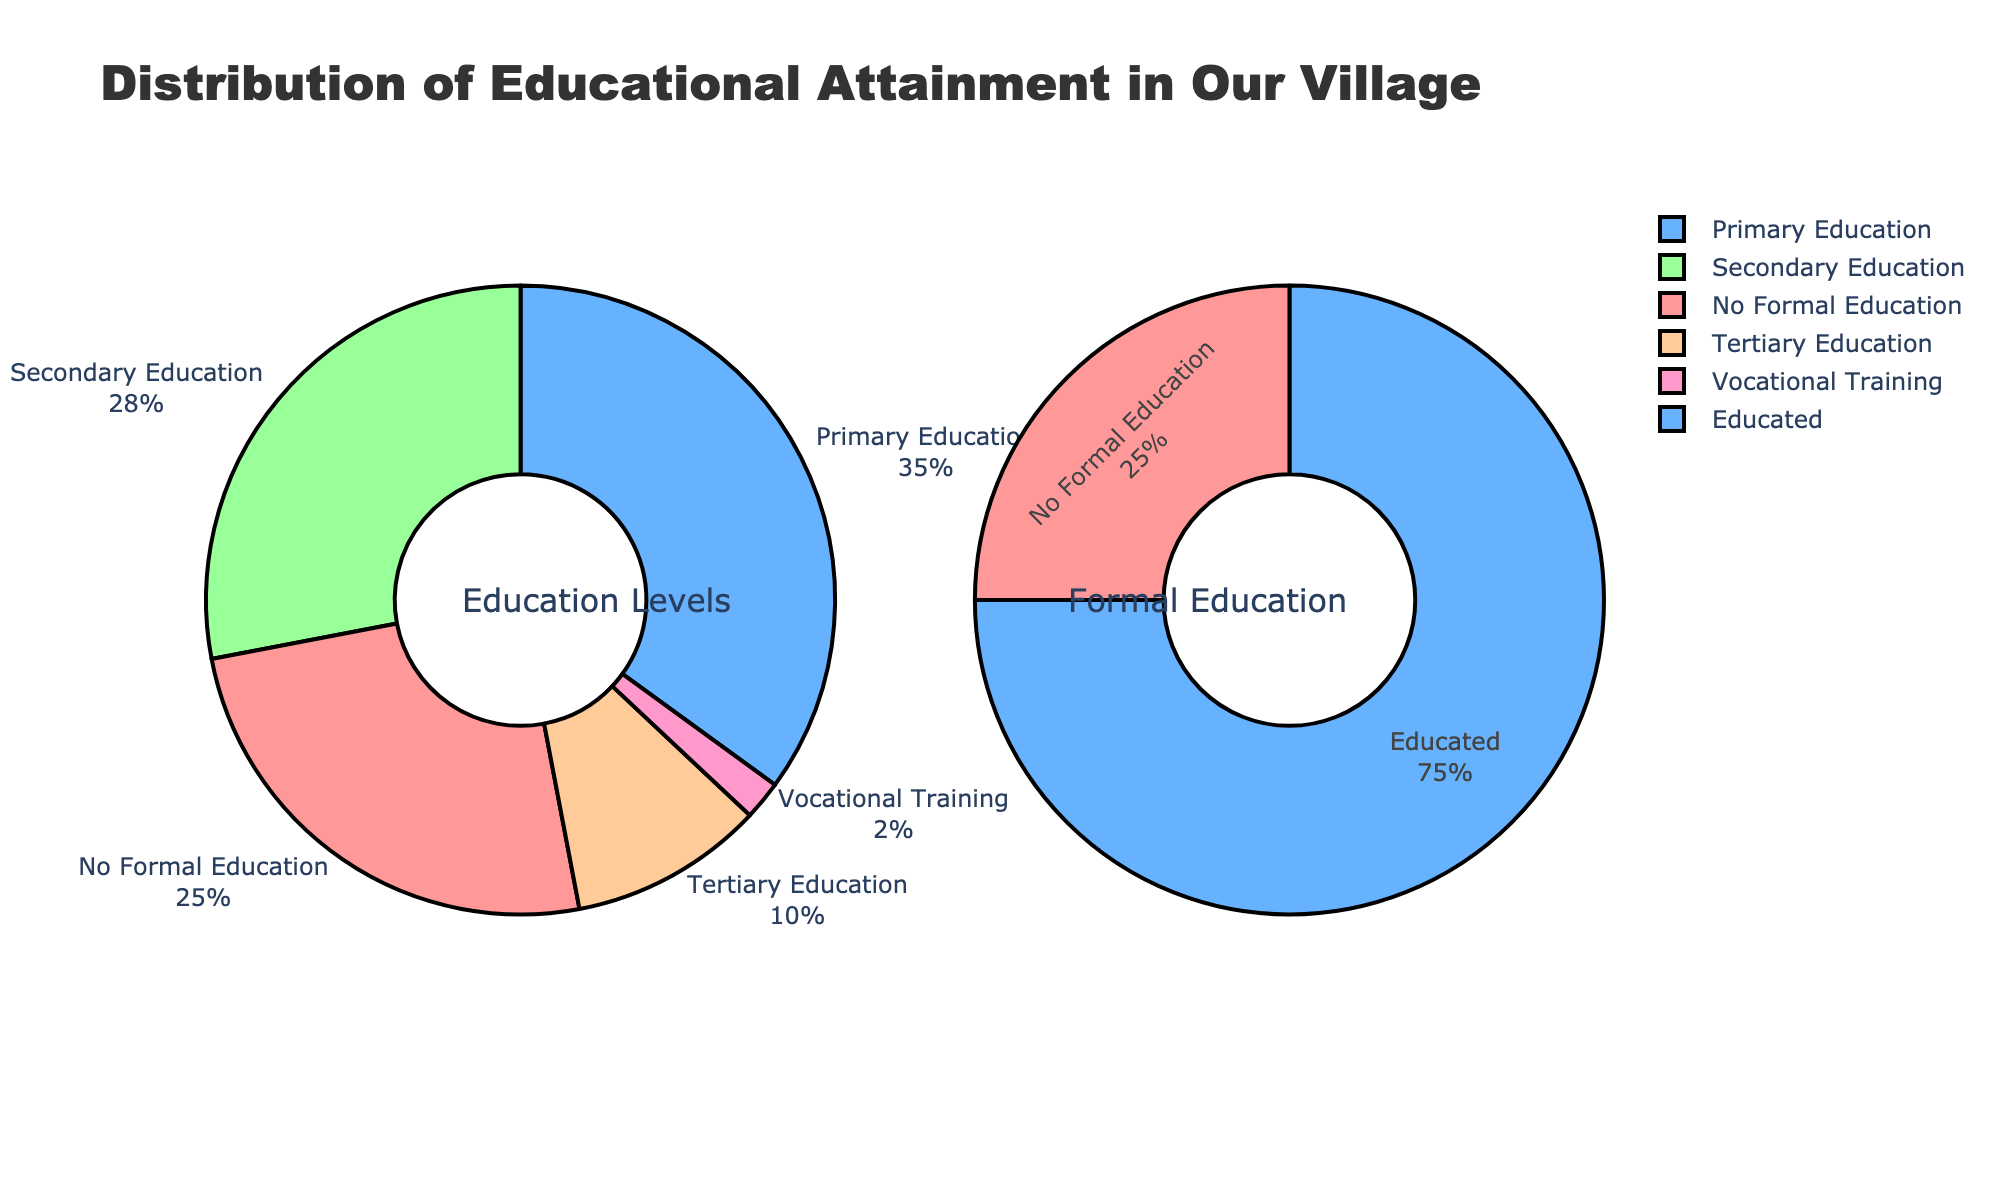What is the title of the chart? The title is prominently displayed at the top of the chart, and it reads "Top Goal Scorers in European Soccer Leagues (Last 5 Seasons)."
Answer: Top Goal Scorers in European Soccer Leagues (Last 5 Seasons) Which league's subplot features Erling Haaland as a top scorer? By examining the subplots, we can see Erling Haaland appears in the Premier League subplot for the 2022/23 season.
Answer: Premier League Who was the top scorer in La Liga for the 2019/20 season? The subplot for La Liga shows Lionel Messi as the top scorer in the 2019/20 season.
Answer: Lionel Messi Which player appeared as the top scorer most frequently in the Bundesliga over the last five seasons? The Bundesliga subplot shows that Robert Lewandowski appeared most frequently as the top scorer, appearing four out of five seasons.
Answer: Robert Lewandowski Which seasons did Mohamed Salah top score in the Premier League? In the Premier League subplot, Mohamed Salah appears as the top scorer in the 2018/19 and 2021/22 seasons.
Answer: 2018/19 and 2021/22 Who was the top scorer in Serie A in the 2020/21 and 2022/23 seasons? The Serie A subplot indicates that Cristiano Ronaldo was the top scorer for the 2020/21 season and Victor Osimhen for the 2022/23 season.
Answer: Cristiano Ronaldo and Victor Osimhen In which league and season did Christopher Nkunku appear as the top scorer? The subplot for Bundesliga shows Christopher Nkunku as the top scorer for the 2022/23 season.
Answer: Bundesliga, 2022/23 How many unique players are featured in the La Liga subplot? By counting the unique players identified in the La Liga subplot, we see that there are three: Lionel Messi, Karim Benzema, and Robert Lewandowski.
Answer: Three Comparing the Premier League and Serie A, which league has more unique top scorers over the five seasons? The Premier League subplot shows five unique top scorers, while the Serie A subplot shows four. Hence, the Premier League has more unique top scorers.
Answer: Premier League Who scored the most frequently in Serie A, and how does this compare to Bundesliga's most frequent scorer? Ciro Immobile appears the most frequently in Serie A for two seasons, while Robert Lewandowski appears the most frequently in Bundesliga for four seasons.
Answer: Ciro Immobile, Robert Lewandowski 